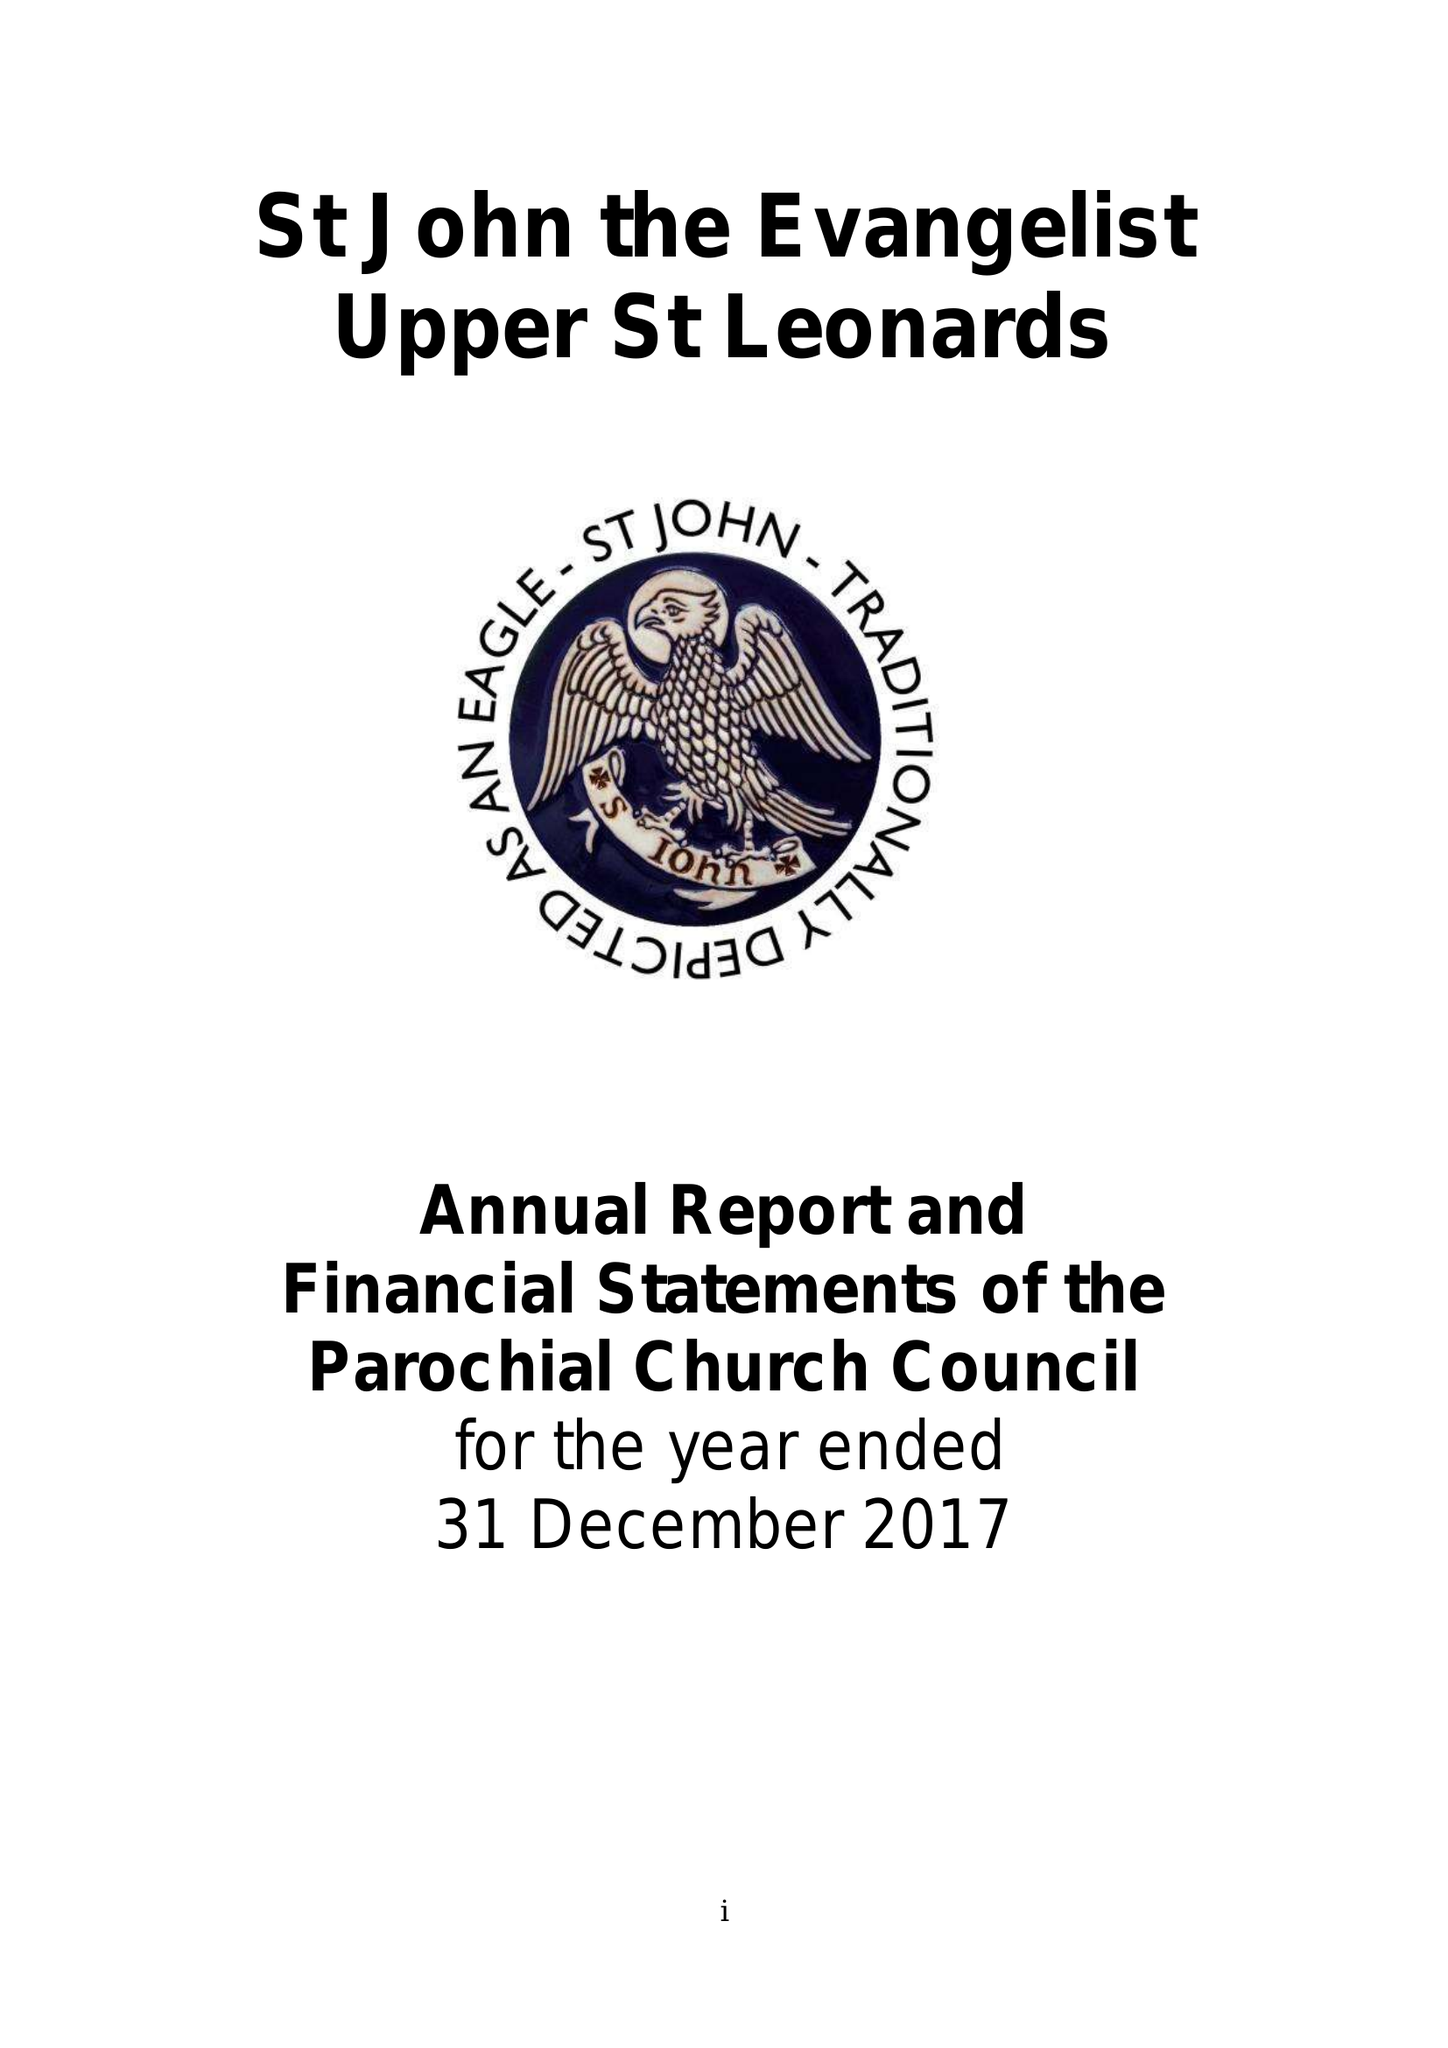What is the value for the income_annually_in_british_pounds?
Answer the question using a single word or phrase. 216728.00 